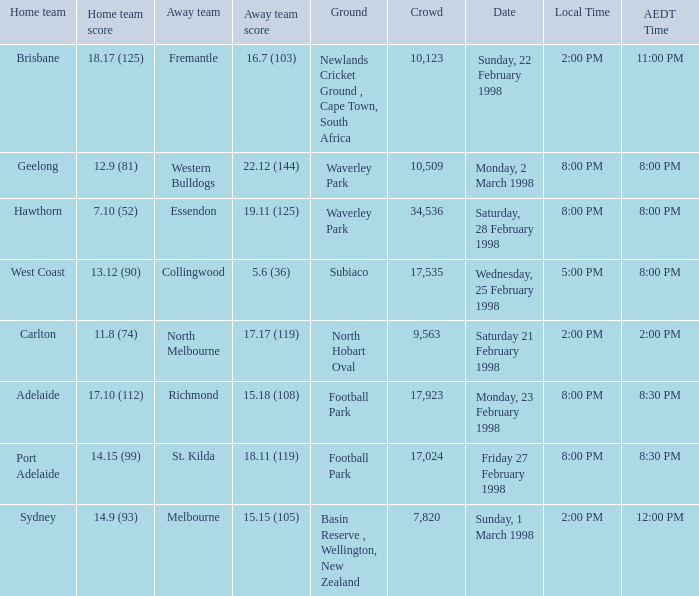Name the AEDT Time which has an Away team of collingwood? 8:00 PM. 